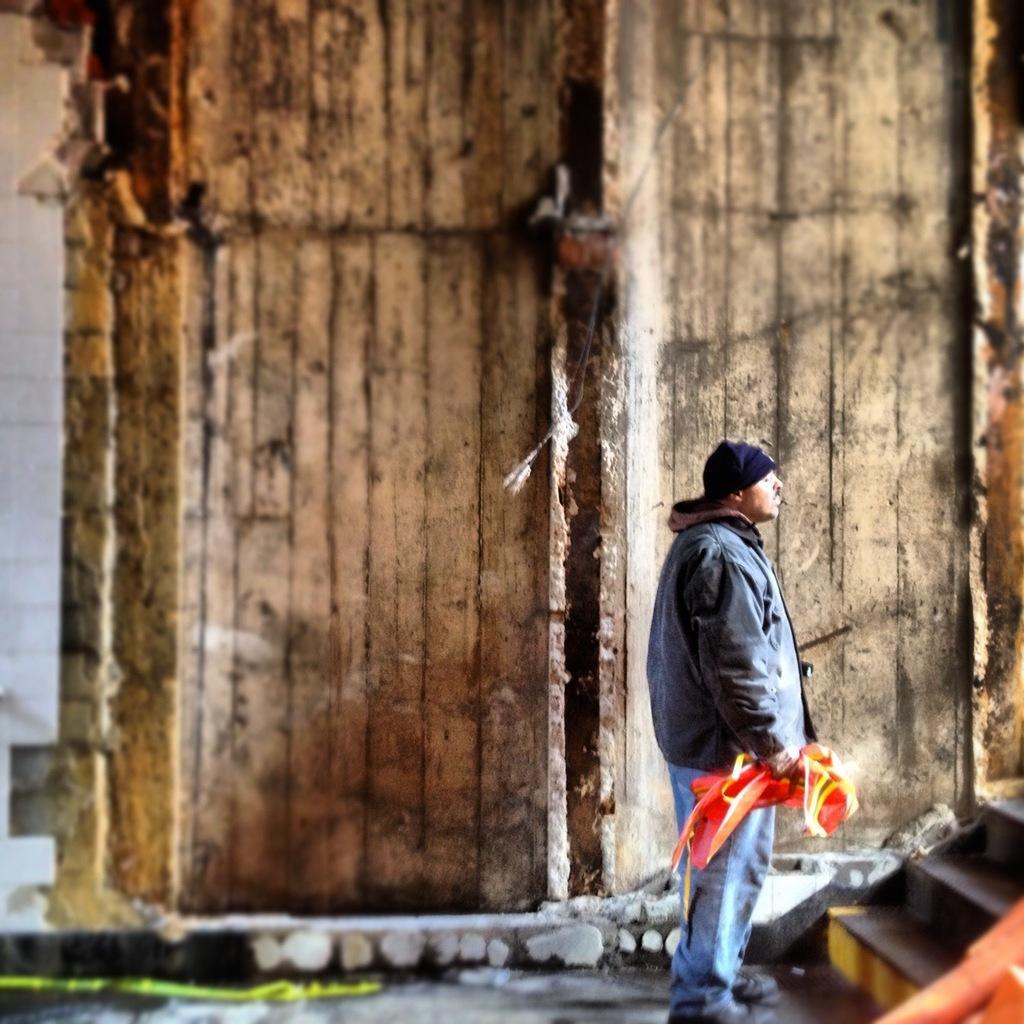Could you give a brief overview of what you see in this image? In this image we can see one wall in the background, few objects attached to the wall, two objects on the ground, one staircase, one man standing and holding an object near the staircase. 